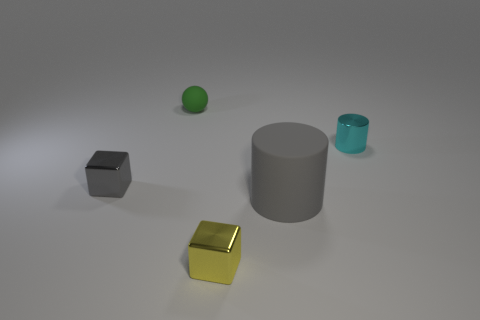Add 2 small cylinders. How many objects exist? 7 Subtract all cylinders. How many objects are left? 3 Add 5 big gray matte cylinders. How many big gray matte cylinders exist? 6 Subtract 1 cyan cylinders. How many objects are left? 4 Subtract all small green matte objects. Subtract all big gray things. How many objects are left? 3 Add 2 shiny cylinders. How many shiny cylinders are left? 3 